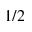Convert formula to latex. <formula><loc_0><loc_0><loc_500><loc_500>1 / 2</formula> 